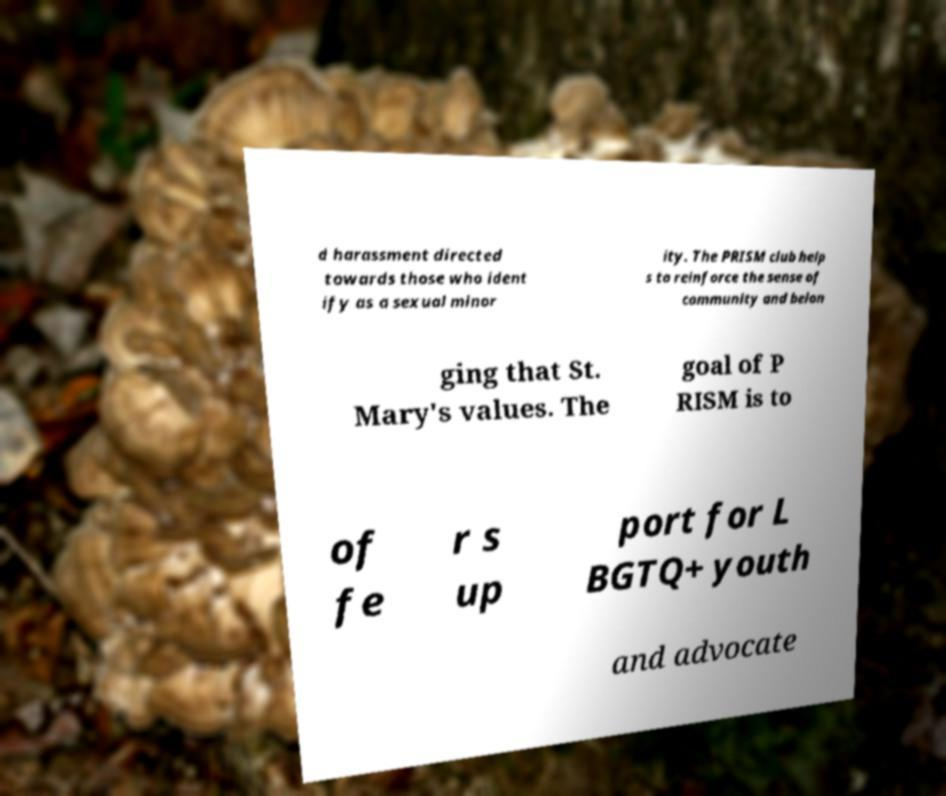Can you accurately transcribe the text from the provided image for me? d harassment directed towards those who ident ify as a sexual minor ity. The PRISM club help s to reinforce the sense of community and belon ging that St. Mary's values. The goal of P RISM is to of fe r s up port for L BGTQ+ youth and advocate 